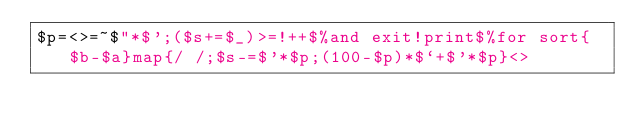<code> <loc_0><loc_0><loc_500><loc_500><_Perl_>$p=<>=~$"*$';($s+=$_)>=!++$%and exit!print$%for sort{$b-$a}map{/ /;$s-=$'*$p;(100-$p)*$`+$'*$p}<></code> 